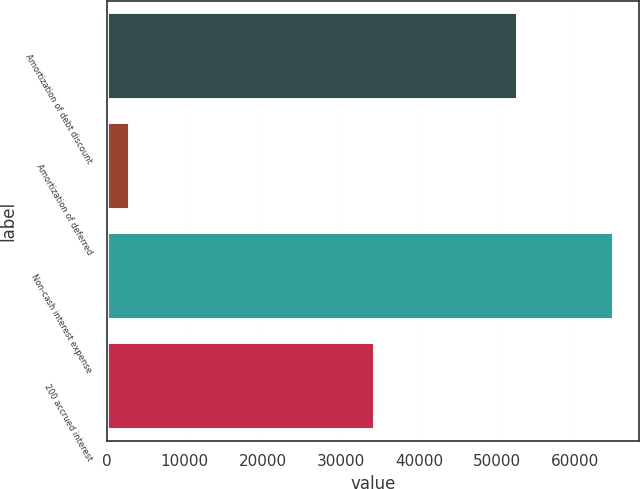Convert chart. <chart><loc_0><loc_0><loc_500><loc_500><bar_chart><fcel>Amortization of debt discount<fcel>Amortization of deferred<fcel>Non-cash interest expense<fcel>200 accrued interest<nl><fcel>52732<fcel>3048<fcel>65005<fcel>34376<nl></chart> 